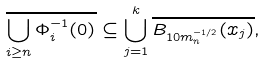Convert formula to latex. <formula><loc_0><loc_0><loc_500><loc_500>\overline { \bigcup _ { i \geq n } \Phi _ { i } ^ { - 1 } ( 0 ) } \subseteq \bigcup _ { j = 1 } ^ { k } \overline { B _ { 1 0 m _ { n } ^ { - 1 / 2 } } ( x _ { j } ) } ,</formula> 